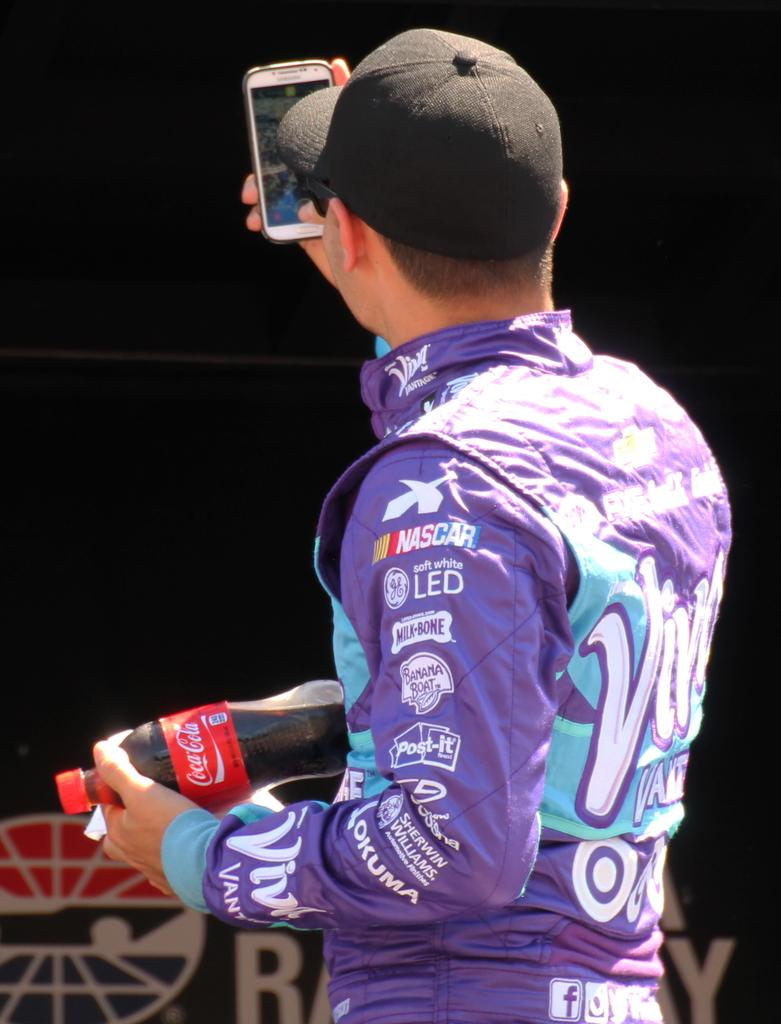<image>
Write a terse but informative summary of the picture. Man wearinga jacket which says Nascar on it. 